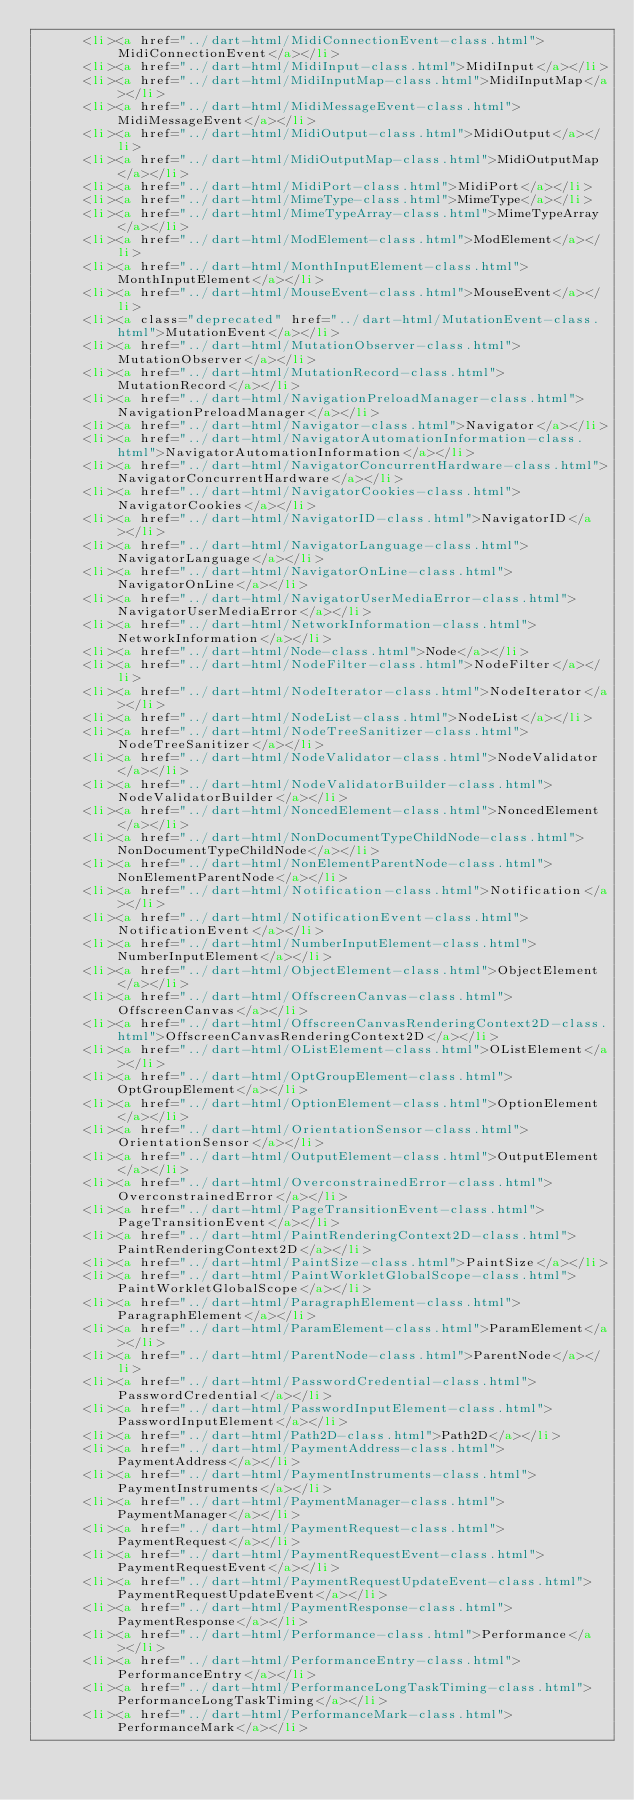Convert code to text. <code><loc_0><loc_0><loc_500><loc_500><_HTML_>      <li><a href="../dart-html/MidiConnectionEvent-class.html">MidiConnectionEvent</a></li>
      <li><a href="../dart-html/MidiInput-class.html">MidiInput</a></li>
      <li><a href="../dart-html/MidiInputMap-class.html">MidiInputMap</a></li>
      <li><a href="../dart-html/MidiMessageEvent-class.html">MidiMessageEvent</a></li>
      <li><a href="../dart-html/MidiOutput-class.html">MidiOutput</a></li>
      <li><a href="../dart-html/MidiOutputMap-class.html">MidiOutputMap</a></li>
      <li><a href="../dart-html/MidiPort-class.html">MidiPort</a></li>
      <li><a href="../dart-html/MimeType-class.html">MimeType</a></li>
      <li><a href="../dart-html/MimeTypeArray-class.html">MimeTypeArray</a></li>
      <li><a href="../dart-html/ModElement-class.html">ModElement</a></li>
      <li><a href="../dart-html/MonthInputElement-class.html">MonthInputElement</a></li>
      <li><a href="../dart-html/MouseEvent-class.html">MouseEvent</a></li>
      <li><a class="deprecated" href="../dart-html/MutationEvent-class.html">MutationEvent</a></li>
      <li><a href="../dart-html/MutationObserver-class.html">MutationObserver</a></li>
      <li><a href="../dart-html/MutationRecord-class.html">MutationRecord</a></li>
      <li><a href="../dart-html/NavigationPreloadManager-class.html">NavigationPreloadManager</a></li>
      <li><a href="../dart-html/Navigator-class.html">Navigator</a></li>
      <li><a href="../dart-html/NavigatorAutomationInformation-class.html">NavigatorAutomationInformation</a></li>
      <li><a href="../dart-html/NavigatorConcurrentHardware-class.html">NavigatorConcurrentHardware</a></li>
      <li><a href="../dart-html/NavigatorCookies-class.html">NavigatorCookies</a></li>
      <li><a href="../dart-html/NavigatorID-class.html">NavigatorID</a></li>
      <li><a href="../dart-html/NavigatorLanguage-class.html">NavigatorLanguage</a></li>
      <li><a href="../dart-html/NavigatorOnLine-class.html">NavigatorOnLine</a></li>
      <li><a href="../dart-html/NavigatorUserMediaError-class.html">NavigatorUserMediaError</a></li>
      <li><a href="../dart-html/NetworkInformation-class.html">NetworkInformation</a></li>
      <li><a href="../dart-html/Node-class.html">Node</a></li>
      <li><a href="../dart-html/NodeFilter-class.html">NodeFilter</a></li>
      <li><a href="../dart-html/NodeIterator-class.html">NodeIterator</a></li>
      <li><a href="../dart-html/NodeList-class.html">NodeList</a></li>
      <li><a href="../dart-html/NodeTreeSanitizer-class.html">NodeTreeSanitizer</a></li>
      <li><a href="../dart-html/NodeValidator-class.html">NodeValidator</a></li>
      <li><a href="../dart-html/NodeValidatorBuilder-class.html">NodeValidatorBuilder</a></li>
      <li><a href="../dart-html/NoncedElement-class.html">NoncedElement</a></li>
      <li><a href="../dart-html/NonDocumentTypeChildNode-class.html">NonDocumentTypeChildNode</a></li>
      <li><a href="../dart-html/NonElementParentNode-class.html">NonElementParentNode</a></li>
      <li><a href="../dart-html/Notification-class.html">Notification</a></li>
      <li><a href="../dart-html/NotificationEvent-class.html">NotificationEvent</a></li>
      <li><a href="../dart-html/NumberInputElement-class.html">NumberInputElement</a></li>
      <li><a href="../dart-html/ObjectElement-class.html">ObjectElement</a></li>
      <li><a href="../dart-html/OffscreenCanvas-class.html">OffscreenCanvas</a></li>
      <li><a href="../dart-html/OffscreenCanvasRenderingContext2D-class.html">OffscreenCanvasRenderingContext2D</a></li>
      <li><a href="../dart-html/OListElement-class.html">OListElement</a></li>
      <li><a href="../dart-html/OptGroupElement-class.html">OptGroupElement</a></li>
      <li><a href="../dart-html/OptionElement-class.html">OptionElement</a></li>
      <li><a href="../dart-html/OrientationSensor-class.html">OrientationSensor</a></li>
      <li><a href="../dart-html/OutputElement-class.html">OutputElement</a></li>
      <li><a href="../dart-html/OverconstrainedError-class.html">OverconstrainedError</a></li>
      <li><a href="../dart-html/PageTransitionEvent-class.html">PageTransitionEvent</a></li>
      <li><a href="../dart-html/PaintRenderingContext2D-class.html">PaintRenderingContext2D</a></li>
      <li><a href="../dart-html/PaintSize-class.html">PaintSize</a></li>
      <li><a href="../dart-html/PaintWorkletGlobalScope-class.html">PaintWorkletGlobalScope</a></li>
      <li><a href="../dart-html/ParagraphElement-class.html">ParagraphElement</a></li>
      <li><a href="../dart-html/ParamElement-class.html">ParamElement</a></li>
      <li><a href="../dart-html/ParentNode-class.html">ParentNode</a></li>
      <li><a href="../dart-html/PasswordCredential-class.html">PasswordCredential</a></li>
      <li><a href="../dart-html/PasswordInputElement-class.html">PasswordInputElement</a></li>
      <li><a href="../dart-html/Path2D-class.html">Path2D</a></li>
      <li><a href="../dart-html/PaymentAddress-class.html">PaymentAddress</a></li>
      <li><a href="../dart-html/PaymentInstruments-class.html">PaymentInstruments</a></li>
      <li><a href="../dart-html/PaymentManager-class.html">PaymentManager</a></li>
      <li><a href="../dart-html/PaymentRequest-class.html">PaymentRequest</a></li>
      <li><a href="../dart-html/PaymentRequestEvent-class.html">PaymentRequestEvent</a></li>
      <li><a href="../dart-html/PaymentRequestUpdateEvent-class.html">PaymentRequestUpdateEvent</a></li>
      <li><a href="../dart-html/PaymentResponse-class.html">PaymentResponse</a></li>
      <li><a href="../dart-html/Performance-class.html">Performance</a></li>
      <li><a href="../dart-html/PerformanceEntry-class.html">PerformanceEntry</a></li>
      <li><a href="../dart-html/PerformanceLongTaskTiming-class.html">PerformanceLongTaskTiming</a></li>
      <li><a href="../dart-html/PerformanceMark-class.html">PerformanceMark</a></li></code> 